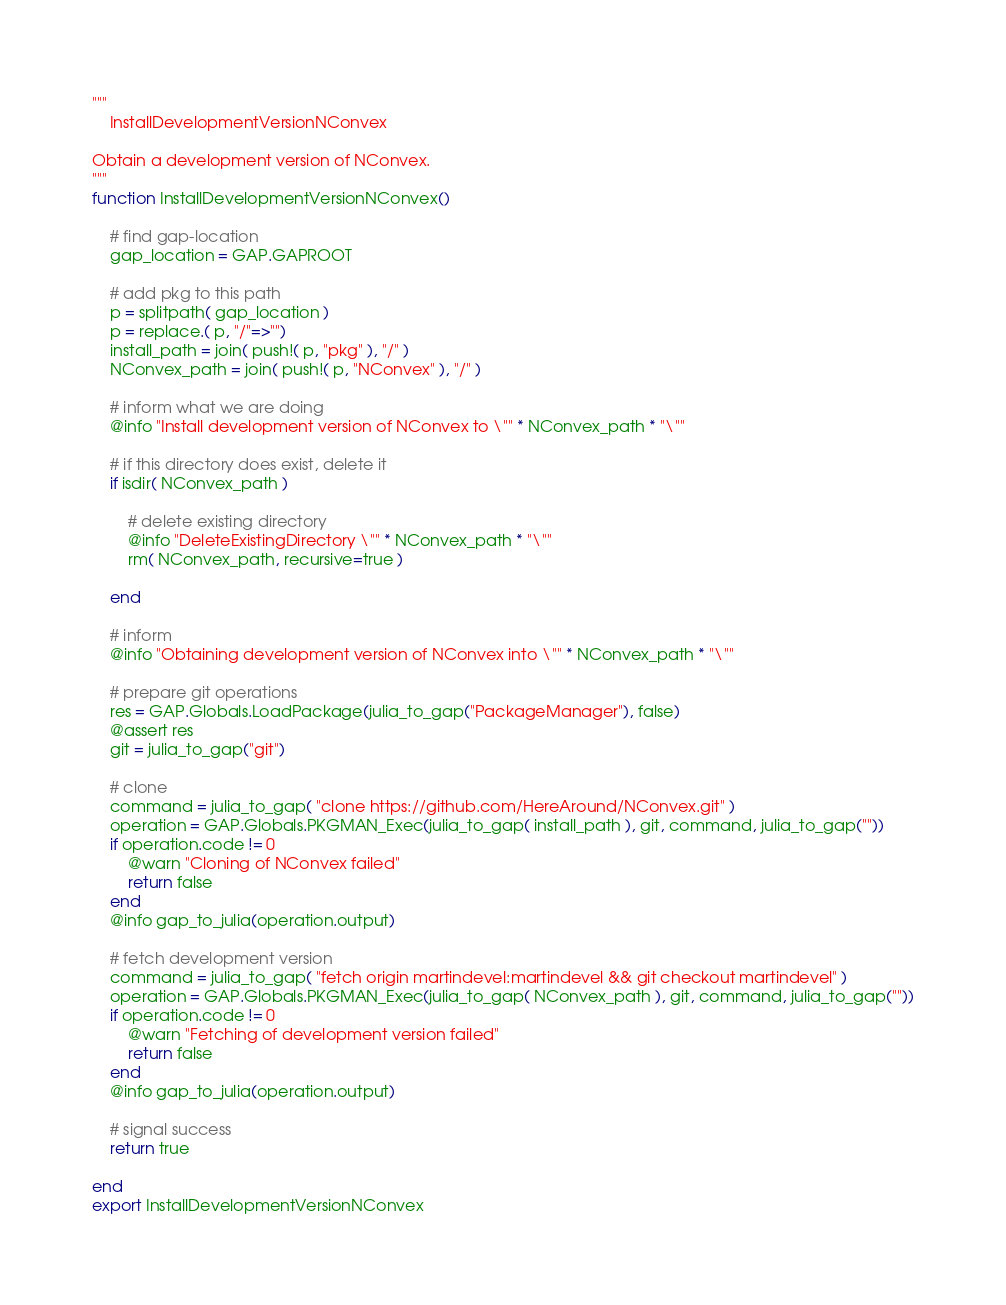<code> <loc_0><loc_0><loc_500><loc_500><_Julia_>
"""
    InstallDevelopmentVersionNConvex

Obtain a development version of NConvex.
"""
function InstallDevelopmentVersionNConvex()

    # find gap-location
    gap_location = GAP.GAPROOT
    
    # add pkg to this path
    p = splitpath( gap_location )
    p = replace.( p, "/"=>"")
    install_path = join( push!( p, "pkg" ), "/" )
    NConvex_path = join( push!( p, "NConvex" ), "/" )

    # inform what we are doing
    @info "Install development version of NConvex to \"" * NConvex_path * "\""
    
    # if this directory does exist, delete it
    if isdir( NConvex_path )

        # delete existing directory
        @info "DeleteExistingDirectory \"" * NConvex_path * "\""
        rm( NConvex_path, recursive=true )
        
    end
            
    # inform
    @info "Obtaining development version of NConvex into \"" * NConvex_path * "\""
        
    # prepare git operations
    res = GAP.Globals.LoadPackage(julia_to_gap("PackageManager"), false)
    @assert res
    git = julia_to_gap("git")
        
    # clone
    command = julia_to_gap( "clone https://github.com/HereAround/NConvex.git" )
    operation = GAP.Globals.PKGMAN_Exec(julia_to_gap( install_path ), git, command, julia_to_gap(""))
    if operation.code != 0
        @warn "Cloning of NConvex failed"
        return false
    end
    @info gap_to_julia(operation.output)
    
    # fetch development version
    command = julia_to_gap( "fetch origin martindevel:martindevel && git checkout martindevel" )
    operation = GAP.Globals.PKGMAN_Exec(julia_to_gap( NConvex_path ), git, command, julia_to_gap(""))
    if operation.code != 0
        @warn "Fetching of development version failed"
        return false
    end
    @info gap_to_julia(operation.output)
    
    # signal success
    return true
    
end
export InstallDevelopmentVersionNConvex
</code> 